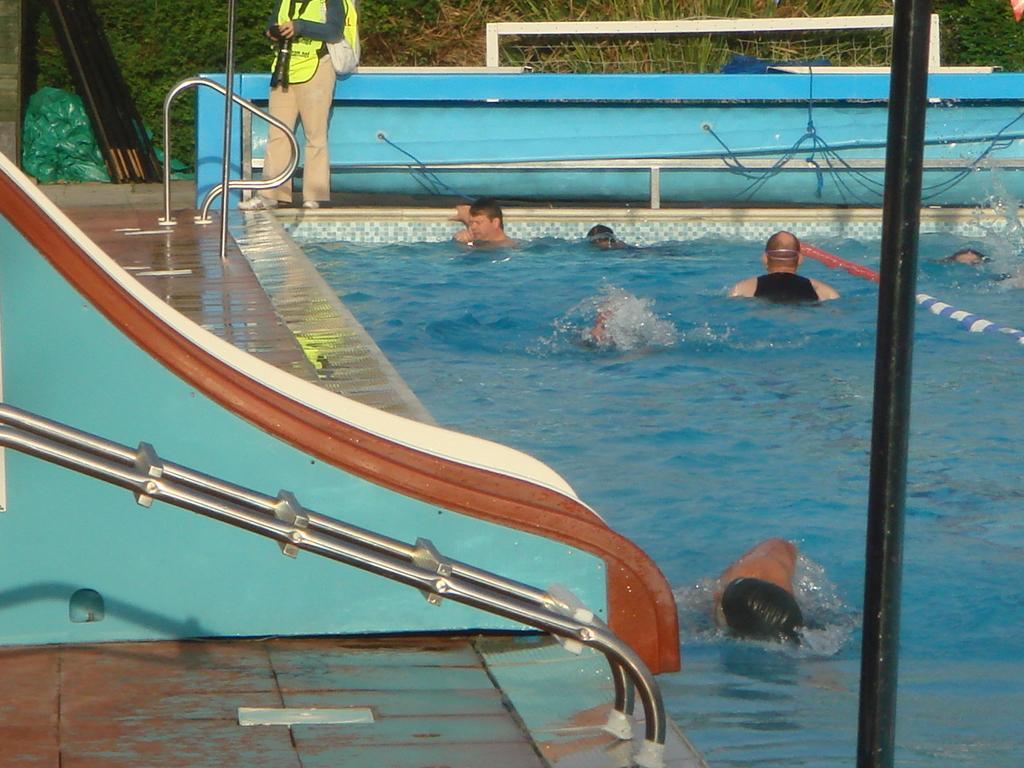In one or two sentences, can you explain what this image depicts? In this image, we can people in the swimming pool and there are rods and we can see a mesh and a person wearing a jacket and wearing a bag and holding an object. In the background, we can see trees and there are bags and a wall and there is a floor. 